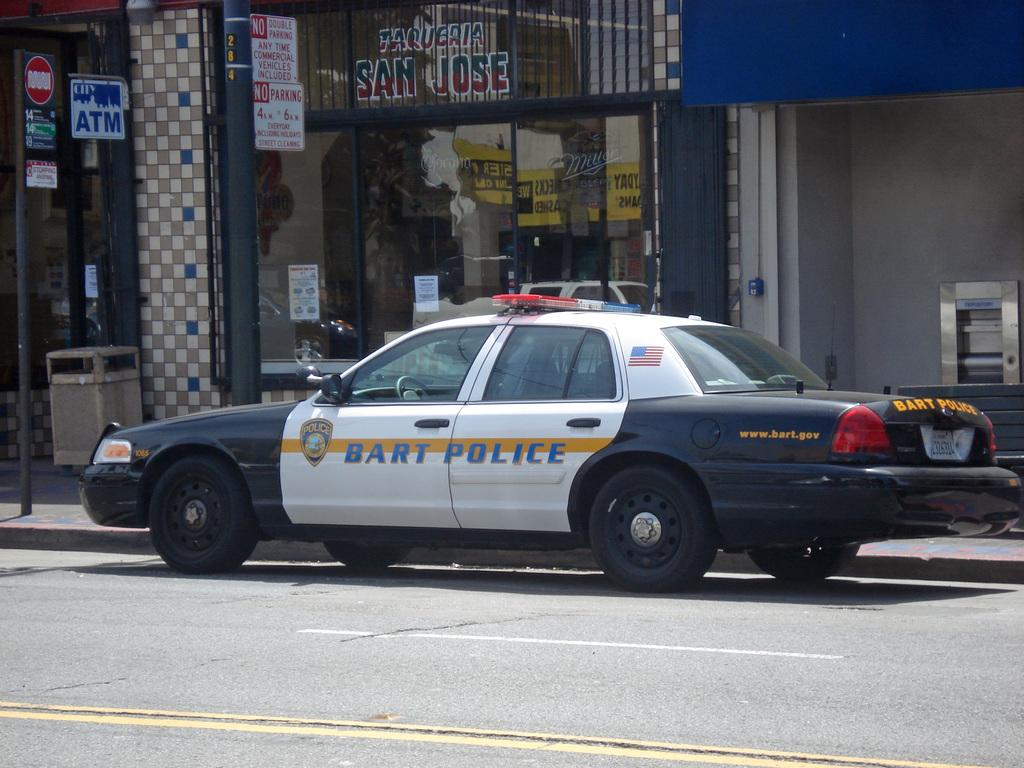What is the main subject of the image? There is a vehicle in the image. Where is the vehicle located? The vehicle is on the road. What can be seen behind the vehicle? There is a building behind the vehicle. What other objects are visible in the background of the image? There are poles and sign boards in the background of the image. What decisions is the committee making about the vehicle in the image? There is no committee present in the image, and therefore no decisions can be made about the vehicle. 